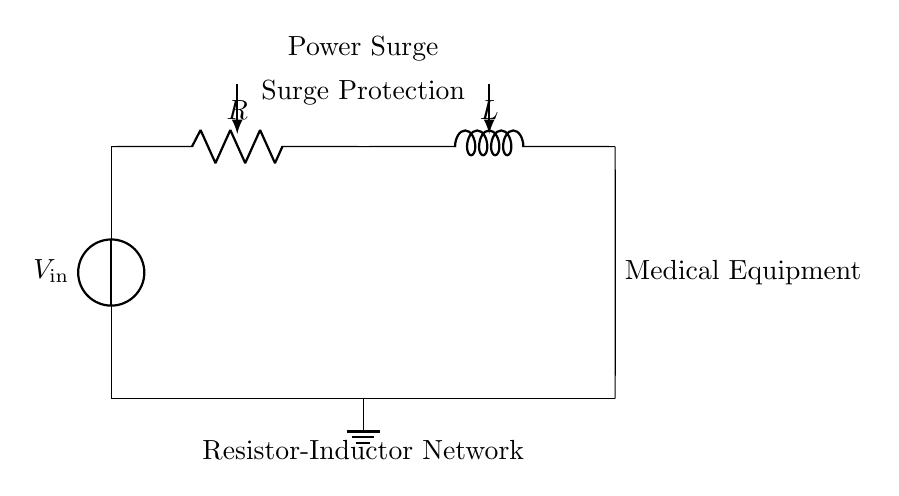What components are present in the circuit? The circuit diagram consists of a resistor and an inductor connected in series. These components are represented with their respective symbols in the diagram.
Answer: Resistor, Inductor What is the purpose of the resistor in this network? The resistor limits the amount of current that can flow through the circuit, providing a measure of protection to connected devices. It dissipates excess energy and helps to manage surges.
Answer: Limit current What is the configuration of the circuit? The resistor and inductor are arranged in series, meaning they are connected end-to-end, forming a single path for the electrical current to flow.
Answer: Series configuration How does the inductor protect medical equipment? The inductor stores energy in a magnetic field when current flows through it and helps to smooth out sudden changes in current, thereby playing a crucial role in protecting sensitive devices from power surges.
Answer: Smooths current What happens during a power surge in this circuit? During a power surge, the energy in the circuit increases, and the inductor will oppose the sudden change, while the resistor will dissipate energy as heat, minimizing the impact on the medical equipment connected.
Answer: Energy is dissipated What is the role of the ground in this circuit? The ground acts as a reference point for the circuit, providing a safe path for excess current to flow in case of a fault or malfunction, which protects the entire system including medical equipment from potential damage.
Answer: Safety path 